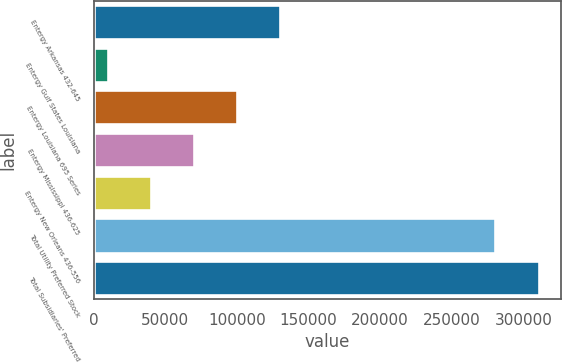Convert chart. <chart><loc_0><loc_0><loc_500><loc_500><bar_chart><fcel>Entergy Arkansas 432-645<fcel>Entergy Gulf States Louisiana<fcel>Entergy Louisiana 695 Series<fcel>Entergy Mississippi 436-625<fcel>Entergy New Orleans 436-556<fcel>Total Utility Preferred Stock<fcel>Total Subsidiaries' Preferred<nl><fcel>130295<fcel>10000<fcel>100221<fcel>70147.6<fcel>40073.8<fcel>280511<fcel>310738<nl></chart> 